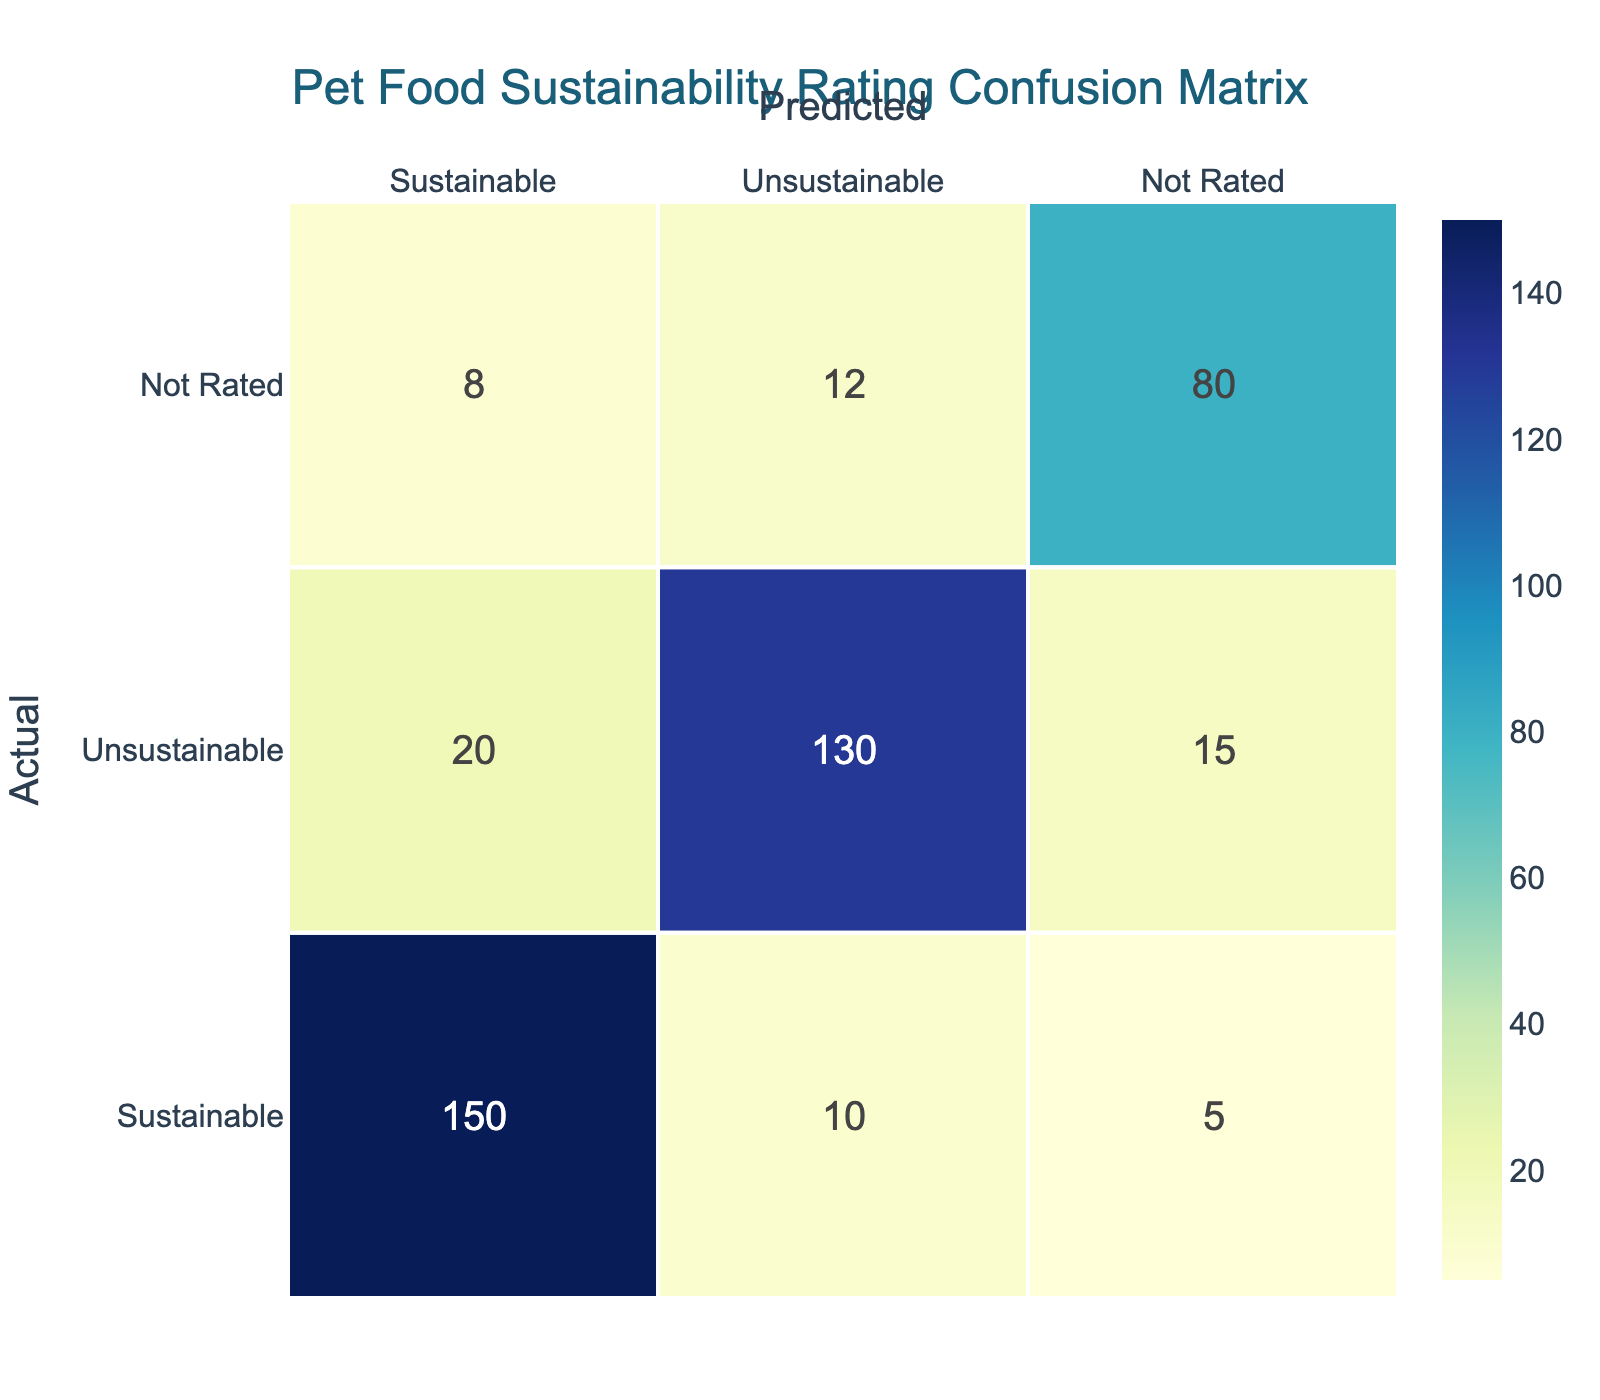What is the count of pet food rated as Sustainable that was also predicted to be Sustainable? Referring to the table, the entry for Actual_Pet_Food_Sustainability_Rating as Sustainable and Predicted_Pet_Food_Sustainability_Rating as Sustainable shows a Count of 150.
Answer: 150 How many pet food ratings were predicted as Unsustainable but were actually Sustainable? Looking at the row where Actual_Pet_Food_Sustainability_Rating is Sustainable and Predicted_Pet_Food_Sustainability_Rating is Unsustainable, the Count is 10.
Answer: 10 What is the sum of pets foods that were rated as Not Rated? Counting the values in the Not Rated row, we find the counts for Sustainable, Unsustainable, and Not Rated respectively are 8, 12, and 80. Thus, 8 + 12 + 80 = 100.
Answer: 100 Is it true that there are more Unsustainable predictions than Sustainable predictions? The number of Unsustainable predictions is the sum of the Unsustainable row (20 + 130 + 15 = 165) and the number of Sustainable predictions is the sum of the Sustainable row (150 + 10 + 5 = 165). Since both are equal, the statement is false.
Answer: No What is the total count of pet foods that were predicted to be Not Rated? Referring to the counts for the Not Rated predictions across all actual sustainability ratings, we see they are 5 (from Sustainable) + 15 (from Unsustainable) + 80 (from Not Rated), totaling 100.
Answer: 100 How many pet foods were both actually Unsustainable and predicted to be Unsustainable? The entry for Actual_Pet_Food_Sustainability_Rating as Unsustainable and Predicted_Pet_Food_Sustainability_Rating as Unsustainable shows a Count of 130, reflecting the count for both categories being the same.
Answer: 130 What is the difference between the count of Sustainable predictions and Unsustainable predictions? From the table, the total count of Sustainable predictions is 150 + 10 + 5 = 165, and the total count for Unsustainable predictions is 20 + 130 + 15 = 165. The difference is 165 - 165 = 0.
Answer: 0 If we consider ratings predicted as Sustainable but actual ratings were Not Rated, what is that count? The table shows for Actual_Pet_Food_Sustainability_Rating as Not Rated and Predicted_Pet_Food_Sustainability_Rating as Sustainable, the Count is 8. This indicates that 8 pet foods were predicted as Sustainable but were actually Not Rated.
Answer: 8 